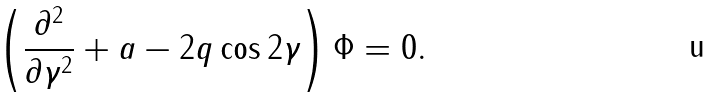<formula> <loc_0><loc_0><loc_500><loc_500>\left ( \frac { \partial ^ { 2 } } { \partial \gamma ^ { 2 } } + a - 2 q \cos 2 \gamma \right ) \Phi = 0 .</formula> 